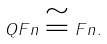<formula> <loc_0><loc_0><loc_500><loc_500>Q F n \cong F n .</formula> 